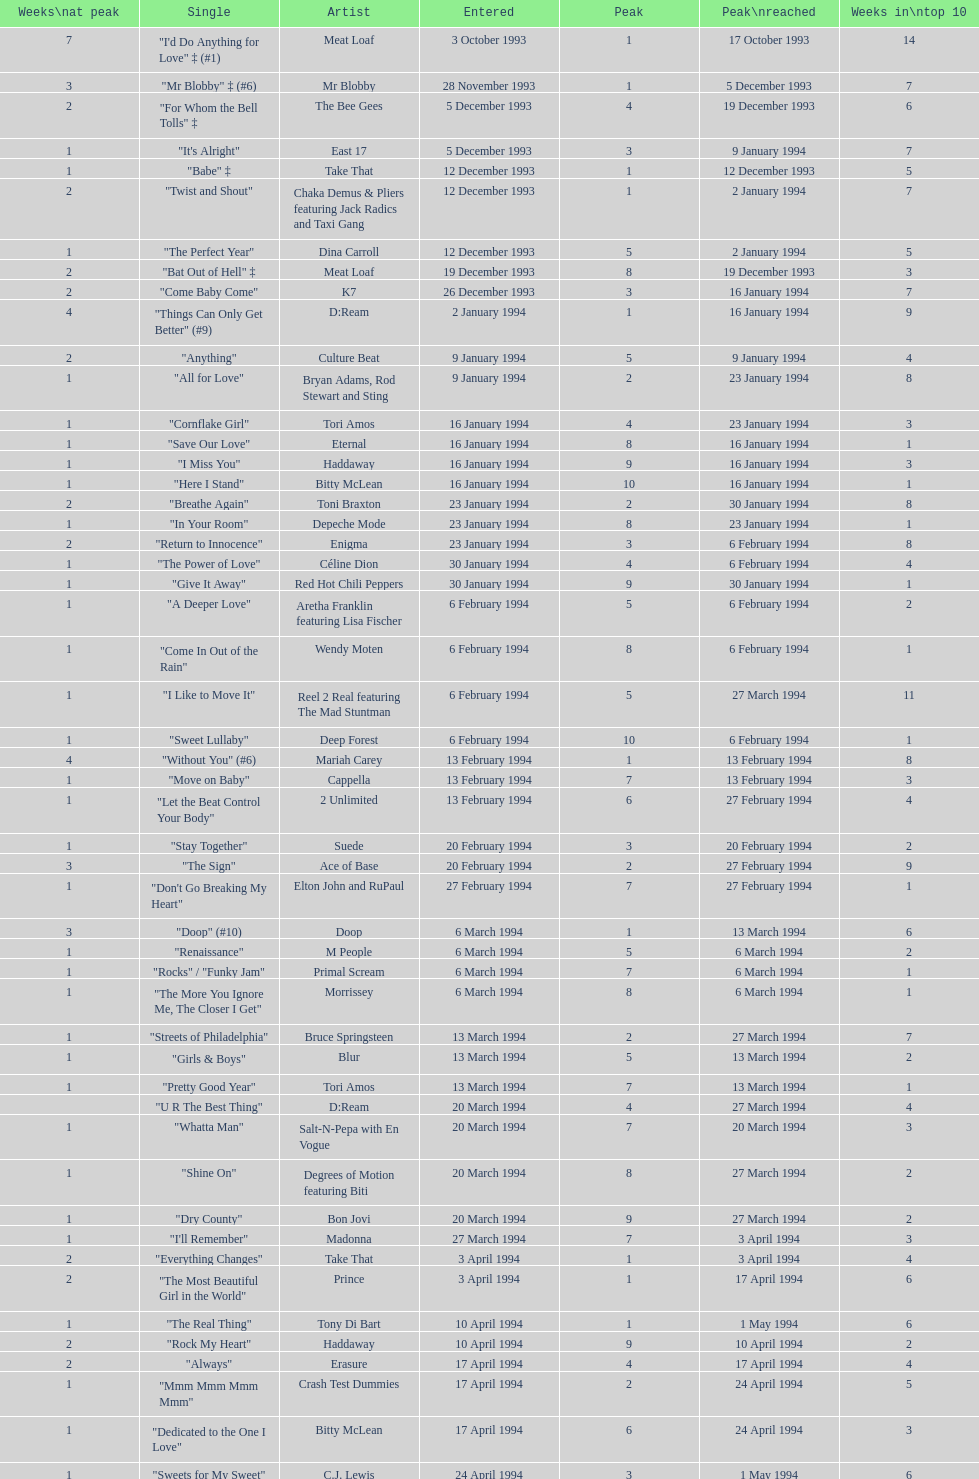What is the first entered date? 3 October 1993. 